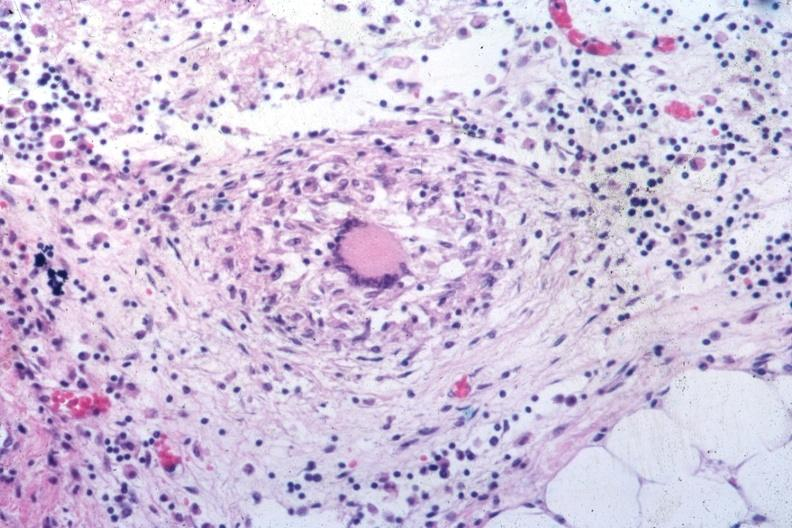s peritoneum present?
Answer the question using a single word or phrase. Yes 